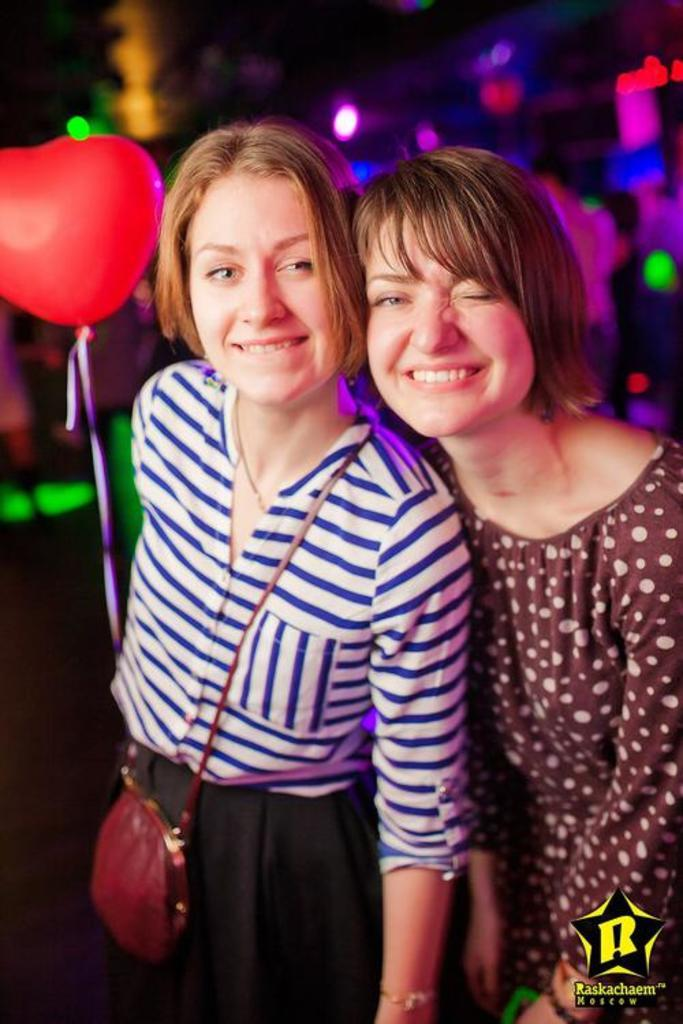Who is present in the image? There are women in the image. What is the position of the women in the image? The women are standing on the ground. What additional object can be seen in the image? There is a balloon in the image. What type of wool is being spun by the squirrel in the image? There is no squirrel or wool present in the image; it features women standing on the ground and a balloon. 